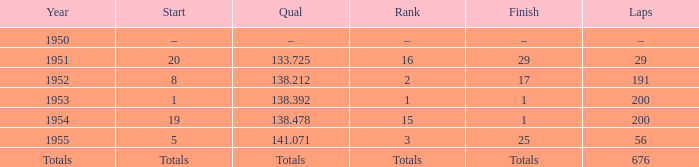212 qualifier? 191.0. 